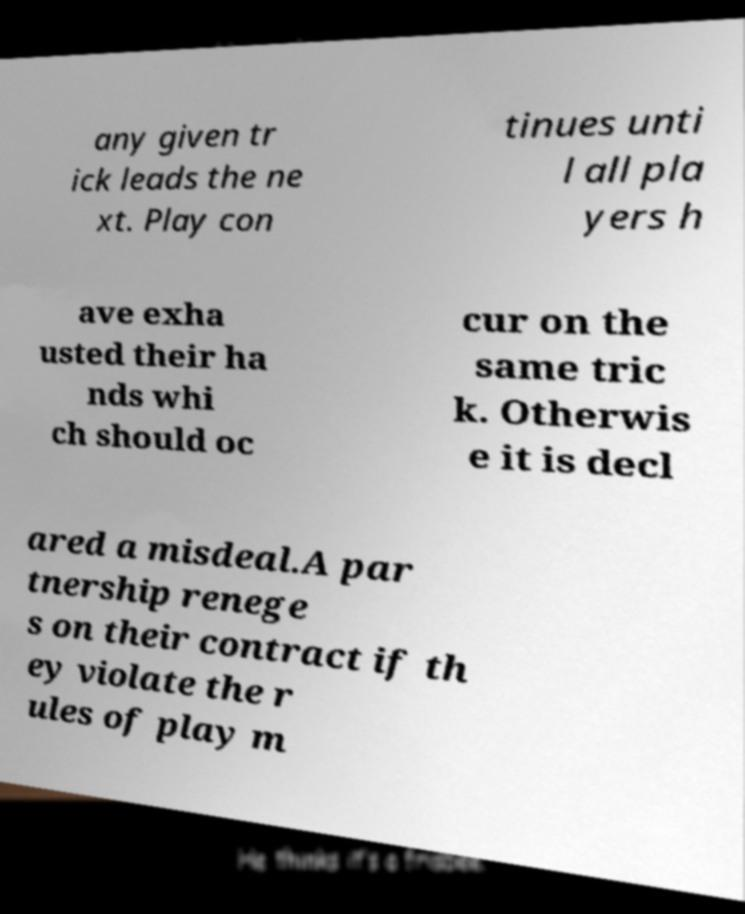What messages or text are displayed in this image? I need them in a readable, typed format. any given tr ick leads the ne xt. Play con tinues unti l all pla yers h ave exha usted their ha nds whi ch should oc cur on the same tric k. Otherwis e it is decl ared a misdeal.A par tnership renege s on their contract if th ey violate the r ules of play m 